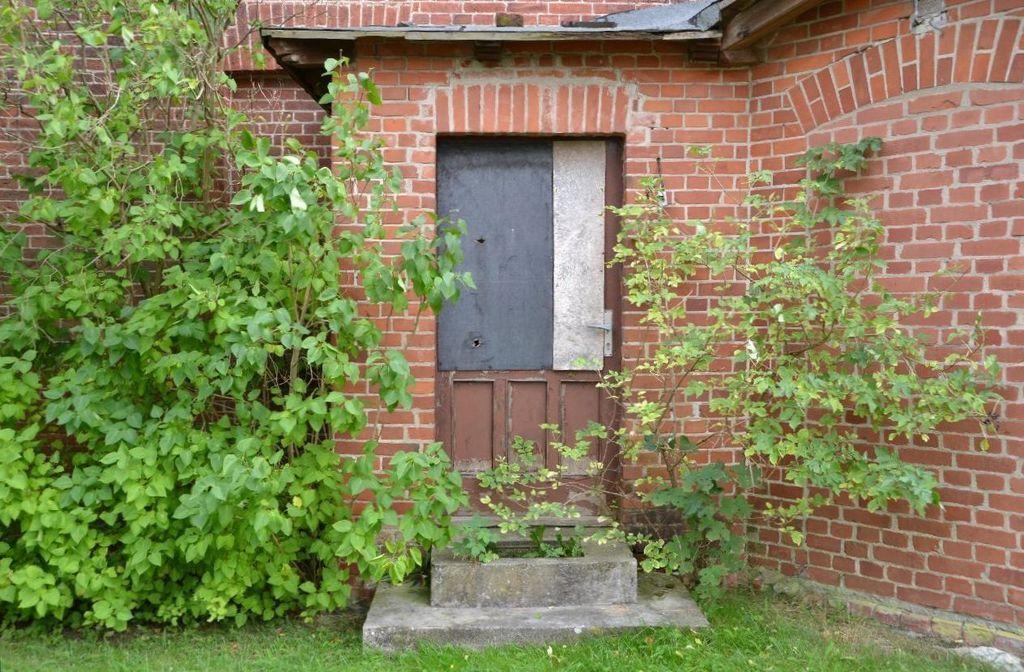Please provide a concise description of this image. In this image there are trees and brick walls in the left and right corner. There is a door in the foreground. And there is a green grass at the bottom. 